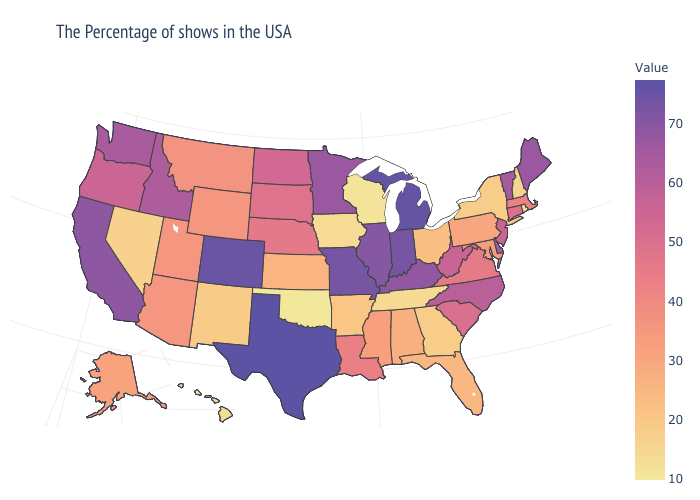Does Louisiana have a lower value than North Dakota?
Be succinct. Yes. 